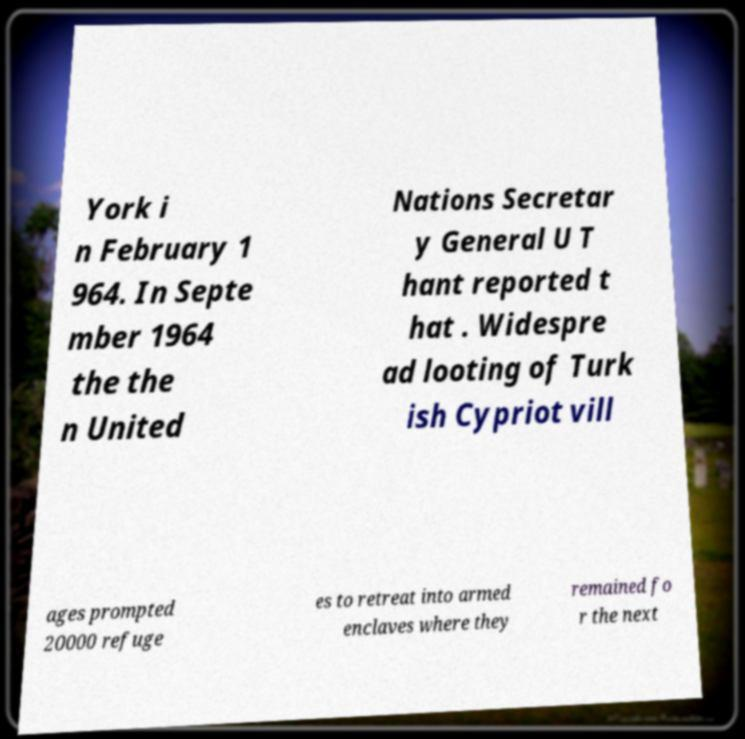Please read and relay the text visible in this image. What does it say? York i n February 1 964. In Septe mber 1964 the the n United Nations Secretar y General U T hant reported t hat . Widespre ad looting of Turk ish Cypriot vill ages prompted 20000 refuge es to retreat into armed enclaves where they remained fo r the next 